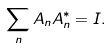Convert formula to latex. <formula><loc_0><loc_0><loc_500><loc_500>\sum _ { n } A _ { n } A ^ { * } _ { n } = I .</formula> 